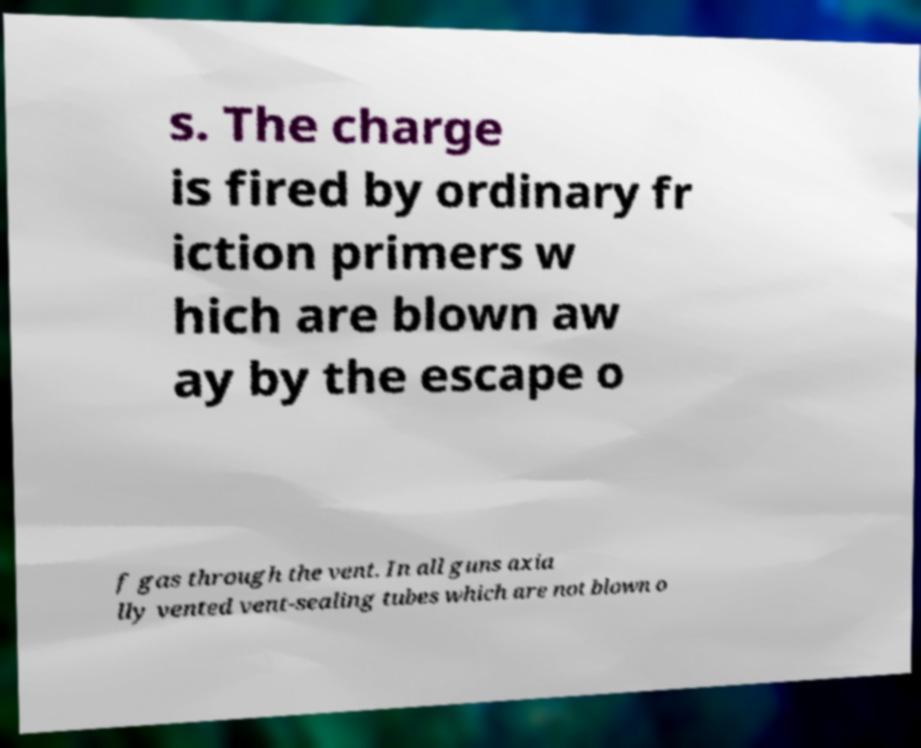What messages or text are displayed in this image? I need them in a readable, typed format. s. The charge is fired by ordinary fr iction primers w hich are blown aw ay by the escape o f gas through the vent. In all guns axia lly vented vent-sealing tubes which are not blown o 